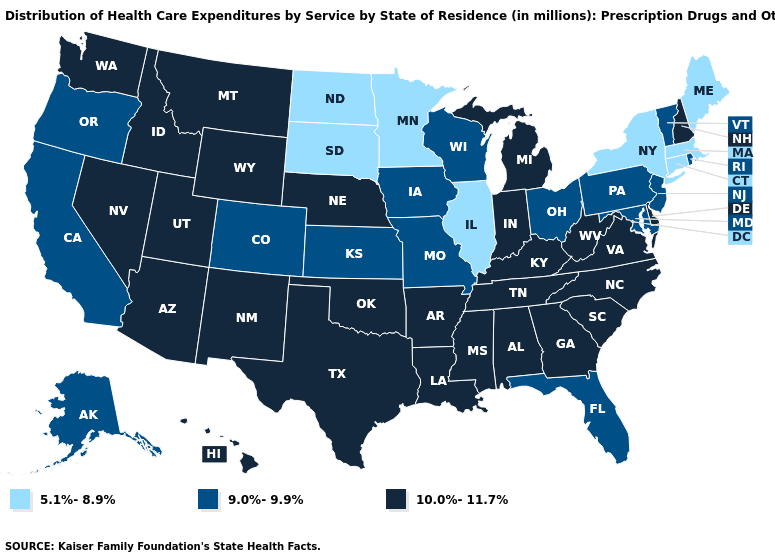Which states have the highest value in the USA?
Concise answer only. Alabama, Arizona, Arkansas, Delaware, Georgia, Hawaii, Idaho, Indiana, Kentucky, Louisiana, Michigan, Mississippi, Montana, Nebraska, Nevada, New Hampshire, New Mexico, North Carolina, Oklahoma, South Carolina, Tennessee, Texas, Utah, Virginia, Washington, West Virginia, Wyoming. Does Maryland have a lower value than South Carolina?
Keep it brief. Yes. Name the states that have a value in the range 5.1%-8.9%?
Short answer required. Connecticut, Illinois, Maine, Massachusetts, Minnesota, New York, North Dakota, South Dakota. Name the states that have a value in the range 5.1%-8.9%?
Write a very short answer. Connecticut, Illinois, Maine, Massachusetts, Minnesota, New York, North Dakota, South Dakota. Does the first symbol in the legend represent the smallest category?
Short answer required. Yes. Does Minnesota have the lowest value in the MidWest?
Give a very brief answer. Yes. What is the lowest value in states that border Vermont?
Give a very brief answer. 5.1%-8.9%. Name the states that have a value in the range 10.0%-11.7%?
Short answer required. Alabama, Arizona, Arkansas, Delaware, Georgia, Hawaii, Idaho, Indiana, Kentucky, Louisiana, Michigan, Mississippi, Montana, Nebraska, Nevada, New Hampshire, New Mexico, North Carolina, Oklahoma, South Carolina, Tennessee, Texas, Utah, Virginia, Washington, West Virginia, Wyoming. Name the states that have a value in the range 10.0%-11.7%?
Quick response, please. Alabama, Arizona, Arkansas, Delaware, Georgia, Hawaii, Idaho, Indiana, Kentucky, Louisiana, Michigan, Mississippi, Montana, Nebraska, Nevada, New Hampshire, New Mexico, North Carolina, Oklahoma, South Carolina, Tennessee, Texas, Utah, Virginia, Washington, West Virginia, Wyoming. What is the value of Wyoming?
Concise answer only. 10.0%-11.7%. Which states have the lowest value in the MidWest?
Keep it brief. Illinois, Minnesota, North Dakota, South Dakota. Does Vermont have the lowest value in the Northeast?
Concise answer only. No. What is the lowest value in states that border Oregon?
Quick response, please. 9.0%-9.9%. Does the map have missing data?
Give a very brief answer. No. Name the states that have a value in the range 10.0%-11.7%?
Write a very short answer. Alabama, Arizona, Arkansas, Delaware, Georgia, Hawaii, Idaho, Indiana, Kentucky, Louisiana, Michigan, Mississippi, Montana, Nebraska, Nevada, New Hampshire, New Mexico, North Carolina, Oklahoma, South Carolina, Tennessee, Texas, Utah, Virginia, Washington, West Virginia, Wyoming. 